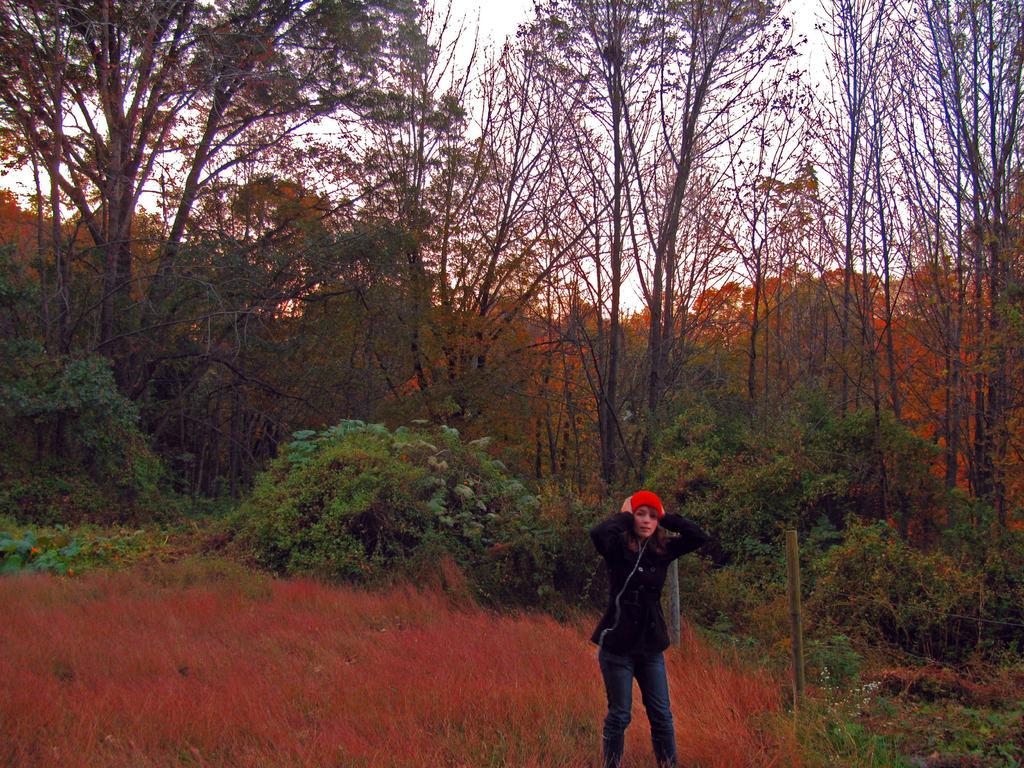How would you summarize this image in a sentence or two? In this image in the center there is a woman standing. In the background there are trees and there are plants. On the ground there is grass. 